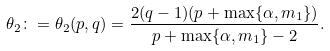<formula> <loc_0><loc_0><loc_500><loc_500>\theta _ { 2 } \colon = \theta _ { 2 } ( p , q ) = \frac { 2 ( q - 1 ) ( p + \max \{ \alpha , m _ { 1 } \} ) } { p + \max \{ \alpha , m _ { 1 } \} - 2 } .</formula> 